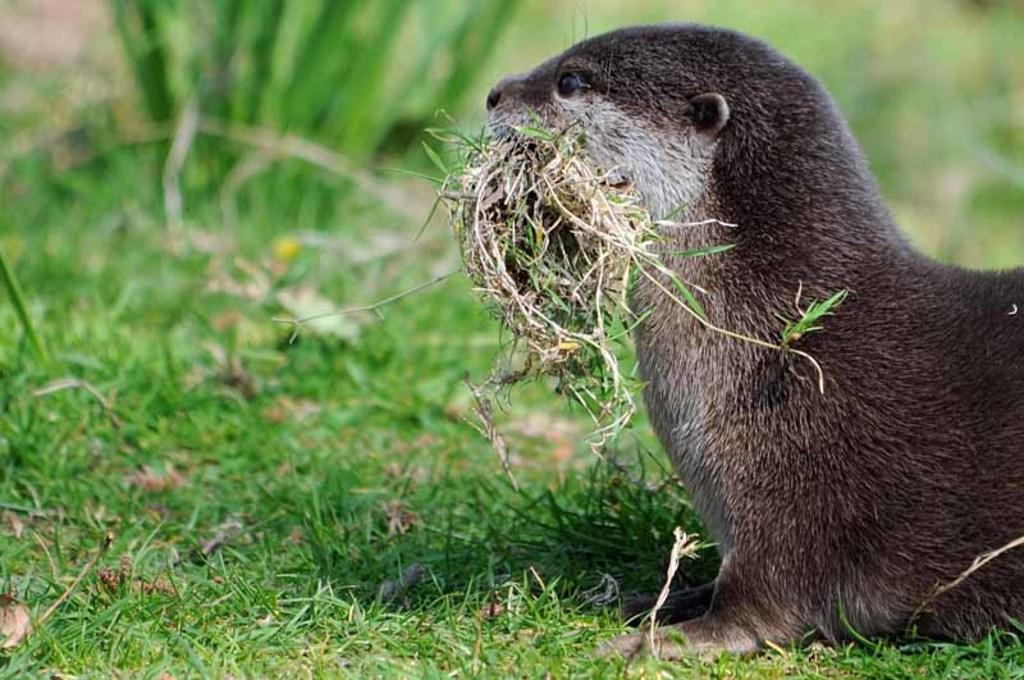What animal is present in the image? There is a beaver in the image. What is the beaver doing in the image? The beaver is eating grass in the image. Where is the beaver located in the image? The beaver is standing on grassland in the image. What type of magic is the beaver performing in the image? There is no magic present in the image; the beaver is simply eating grass. 